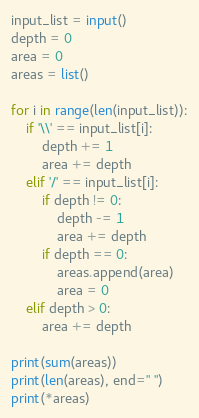<code> <loc_0><loc_0><loc_500><loc_500><_Python_>input_list = input()
depth = 0
area = 0
areas = list()

for i in range(len(input_list)):
    if '\\' == input_list[i]:
        depth += 1
        area += depth
    elif '/' == input_list[i]:
        if depth != 0:
            depth -= 1
            area += depth
        if depth == 0:
            areas.append(area)
            area = 0
    elif depth > 0:
        area += depth

print(sum(areas))
print(len(areas), end=" ")
print(*areas)</code> 